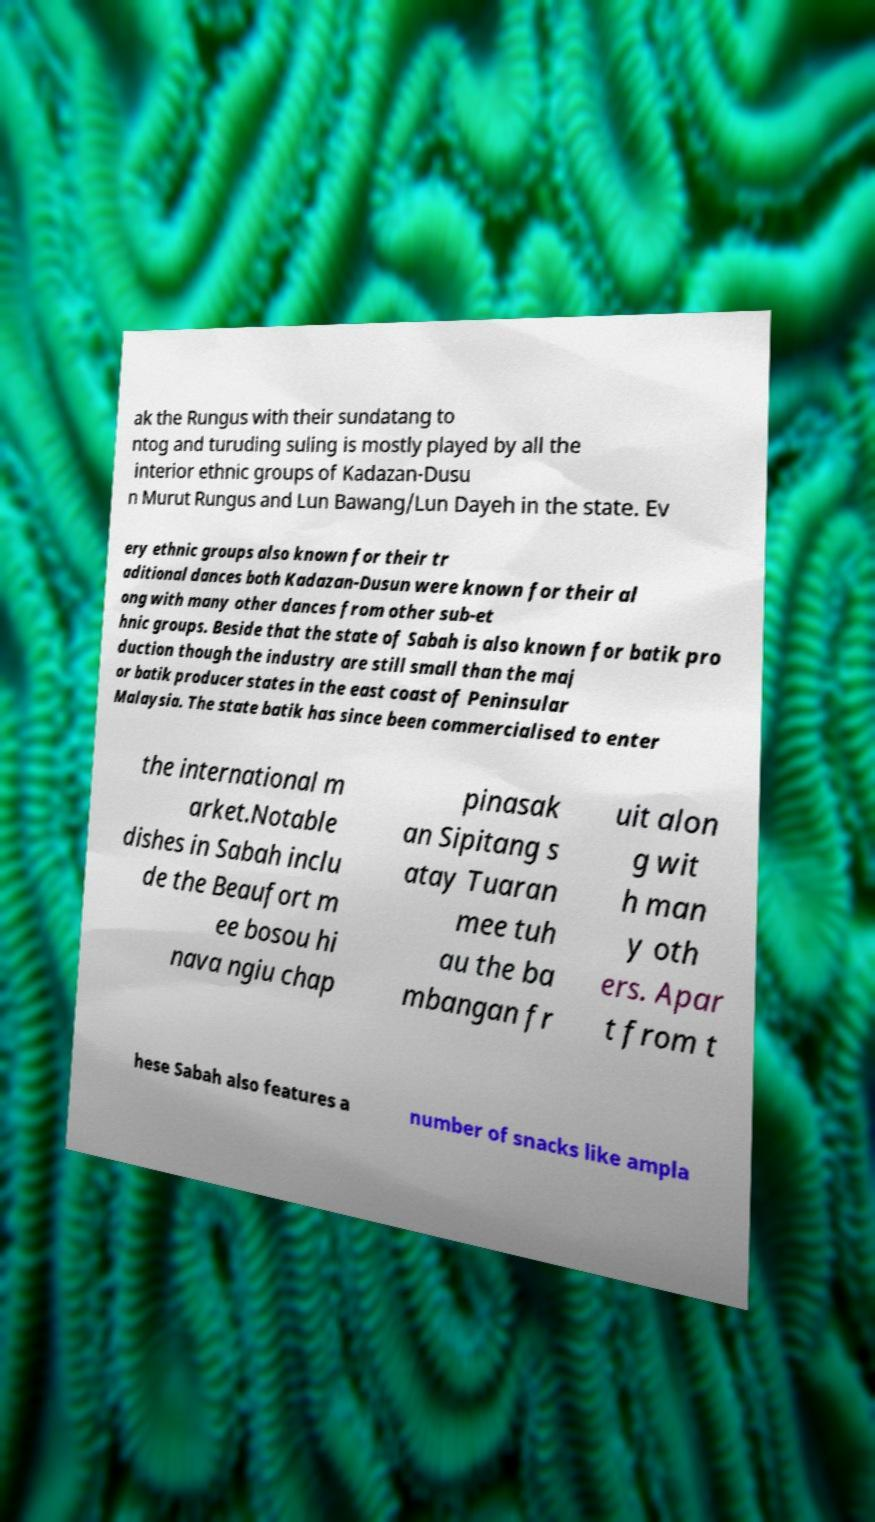Could you extract and type out the text from this image? ak the Rungus with their sundatang to ntog and turuding suling is mostly played by all the interior ethnic groups of Kadazan-Dusu n Murut Rungus and Lun Bawang/Lun Dayeh in the state. Ev ery ethnic groups also known for their tr aditional dances both Kadazan-Dusun were known for their al ong with many other dances from other sub-et hnic groups. Beside that the state of Sabah is also known for batik pro duction though the industry are still small than the maj or batik producer states in the east coast of Peninsular Malaysia. The state batik has since been commercialised to enter the international m arket.Notable dishes in Sabah inclu de the Beaufort m ee bosou hi nava ngiu chap pinasak an Sipitang s atay Tuaran mee tuh au the ba mbangan fr uit alon g wit h man y oth ers. Apar t from t hese Sabah also features a number of snacks like ampla 